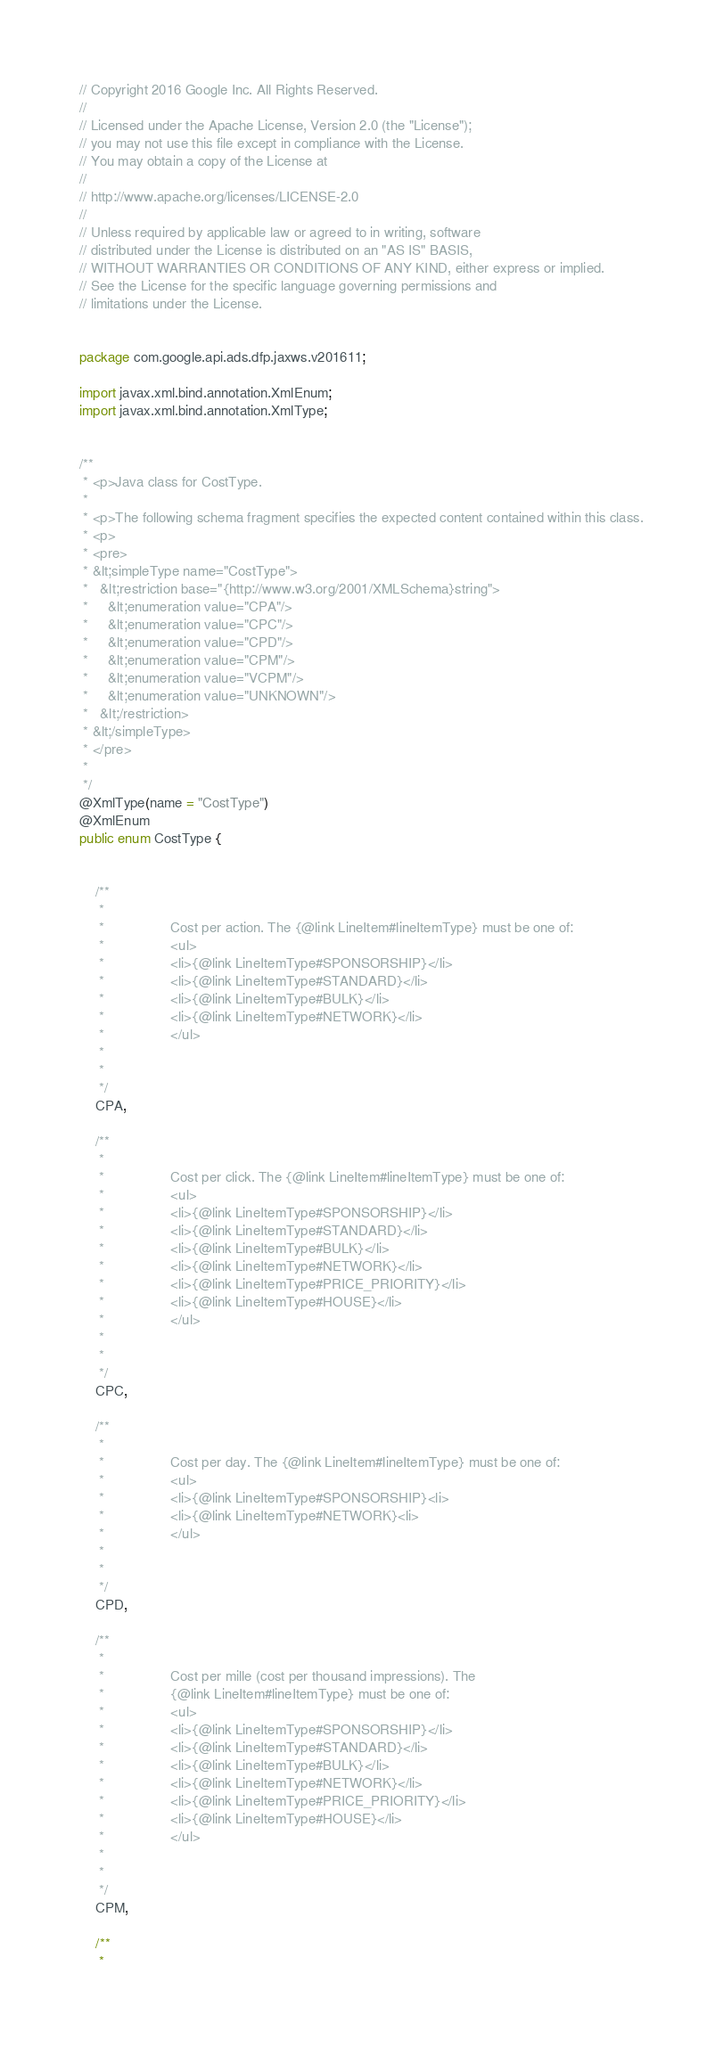<code> <loc_0><loc_0><loc_500><loc_500><_Java_>// Copyright 2016 Google Inc. All Rights Reserved.
//
// Licensed under the Apache License, Version 2.0 (the "License");
// you may not use this file except in compliance with the License.
// You may obtain a copy of the License at
//
// http://www.apache.org/licenses/LICENSE-2.0
//
// Unless required by applicable law or agreed to in writing, software
// distributed under the License is distributed on an "AS IS" BASIS,
// WITHOUT WARRANTIES OR CONDITIONS OF ANY KIND, either express or implied.
// See the License for the specific language governing permissions and
// limitations under the License.


package com.google.api.ads.dfp.jaxws.v201611;

import javax.xml.bind.annotation.XmlEnum;
import javax.xml.bind.annotation.XmlType;


/**
 * <p>Java class for CostType.
 * 
 * <p>The following schema fragment specifies the expected content contained within this class.
 * <p>
 * <pre>
 * &lt;simpleType name="CostType">
 *   &lt;restriction base="{http://www.w3.org/2001/XMLSchema}string">
 *     &lt;enumeration value="CPA"/>
 *     &lt;enumeration value="CPC"/>
 *     &lt;enumeration value="CPD"/>
 *     &lt;enumeration value="CPM"/>
 *     &lt;enumeration value="VCPM"/>
 *     &lt;enumeration value="UNKNOWN"/>
 *   &lt;/restriction>
 * &lt;/simpleType>
 * </pre>
 * 
 */
@XmlType(name = "CostType")
@XmlEnum
public enum CostType {


    /**
     * 
     *                 Cost per action. The {@link LineItem#lineItemType} must be one of:
     *                 <ul>
     *                 <li>{@link LineItemType#SPONSORSHIP}</li>
     *                 <li>{@link LineItemType#STANDARD}</li>
     *                 <li>{@link LineItemType#BULK}</li>
     *                 <li>{@link LineItemType#NETWORK}</li>
     *                 </ul>
     *               
     * 
     */
    CPA,

    /**
     * 
     *                 Cost per click. The {@link LineItem#lineItemType} must be one of:
     *                 <ul>
     *                 <li>{@link LineItemType#SPONSORSHIP}</li>
     *                 <li>{@link LineItemType#STANDARD}</li>
     *                 <li>{@link LineItemType#BULK}</li>
     *                 <li>{@link LineItemType#NETWORK}</li>
     *                 <li>{@link LineItemType#PRICE_PRIORITY}</li>
     *                 <li>{@link LineItemType#HOUSE}</li>
     *                 </ul>
     *               
     * 
     */
    CPC,

    /**
     * 
     *                 Cost per day. The {@link LineItem#lineItemType} must be one of:
     *                 <ul>
     *                 <li>{@link LineItemType#SPONSORSHIP}<li>
     *                 <li>{@link LineItemType#NETWORK}<li>
     *                 </ul>
     *               
     * 
     */
    CPD,

    /**
     * 
     *                 Cost per mille (cost per thousand impressions). The
     *                 {@link LineItem#lineItemType} must be one of:
     *                 <ul>
     *                 <li>{@link LineItemType#SPONSORSHIP}</li>
     *                 <li>{@link LineItemType#STANDARD}</li>
     *                 <li>{@link LineItemType#BULK}</li>
     *                 <li>{@link LineItemType#NETWORK}</li>
     *                 <li>{@link LineItemType#PRICE_PRIORITY}</li>
     *                 <li>{@link LineItemType#HOUSE}</li>
     *                 </ul>
     *               
     * 
     */
    CPM,

    /**
     * </code> 